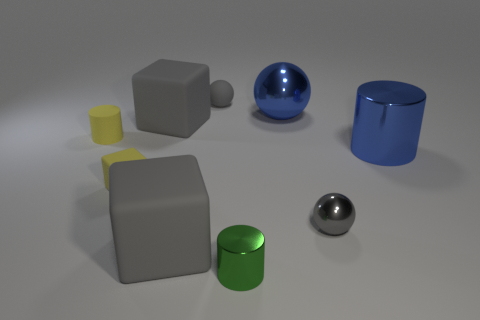Is the number of blue metal cylinders less than the number of small purple metal cylinders?
Make the answer very short. No. There is a gray thing that is made of the same material as the green object; what size is it?
Provide a succinct answer. Small. The rubber ball is what size?
Make the answer very short. Small. What is the shape of the small green metallic thing?
Offer a terse response. Cylinder. Is the color of the large block that is behind the yellow cylinder the same as the large metal sphere?
Ensure brevity in your answer.  No. What is the size of the yellow matte thing that is the same shape as the green shiny object?
Ensure brevity in your answer.  Small. Is there a gray matte cube left of the cylinder left of the large rubber object behind the small matte cylinder?
Offer a terse response. No. What is the tiny gray thing to the right of the gray matte ball made of?
Give a very brief answer. Metal. What number of tiny objects are either yellow rubber cylinders or green objects?
Provide a short and direct response. 2. There is a gray matte ball that is behind the gray metal sphere; does it have the same size as the big blue metal ball?
Your answer should be very brief. No. 